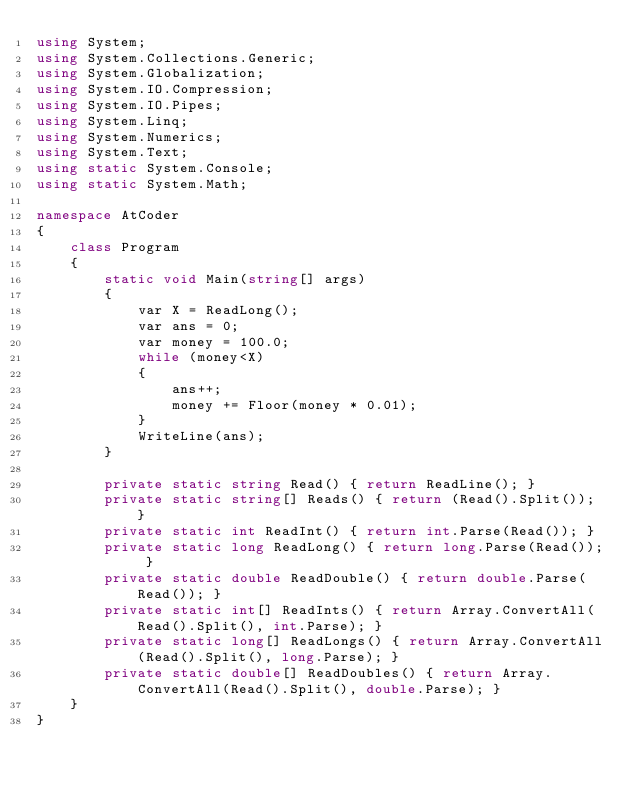Convert code to text. <code><loc_0><loc_0><loc_500><loc_500><_C#_>using System;
using System.Collections.Generic;
using System.Globalization;
using System.IO.Compression;
using System.IO.Pipes;
using System.Linq;
using System.Numerics;
using System.Text;
using static System.Console;
using static System.Math;

namespace AtCoder
{
    class Program
    {
        static void Main(string[] args)
        {
            var X = ReadLong();
            var ans = 0;
            var money = 100.0;
            while (money<X)
            {
                ans++;
                money += Floor(money * 0.01);
            }
            WriteLine(ans);
        }

        private static string Read() { return ReadLine(); }
        private static string[] Reads() { return (Read().Split()); }
        private static int ReadInt() { return int.Parse(Read()); }
        private static long ReadLong() { return long.Parse(Read()); }
        private static double ReadDouble() { return double.Parse(Read()); }
        private static int[] ReadInts() { return Array.ConvertAll(Read().Split(), int.Parse); }
        private static long[] ReadLongs() { return Array.ConvertAll(Read().Split(), long.Parse); }
        private static double[] ReadDoubles() { return Array.ConvertAll(Read().Split(), double.Parse); }
    }
}
</code> 